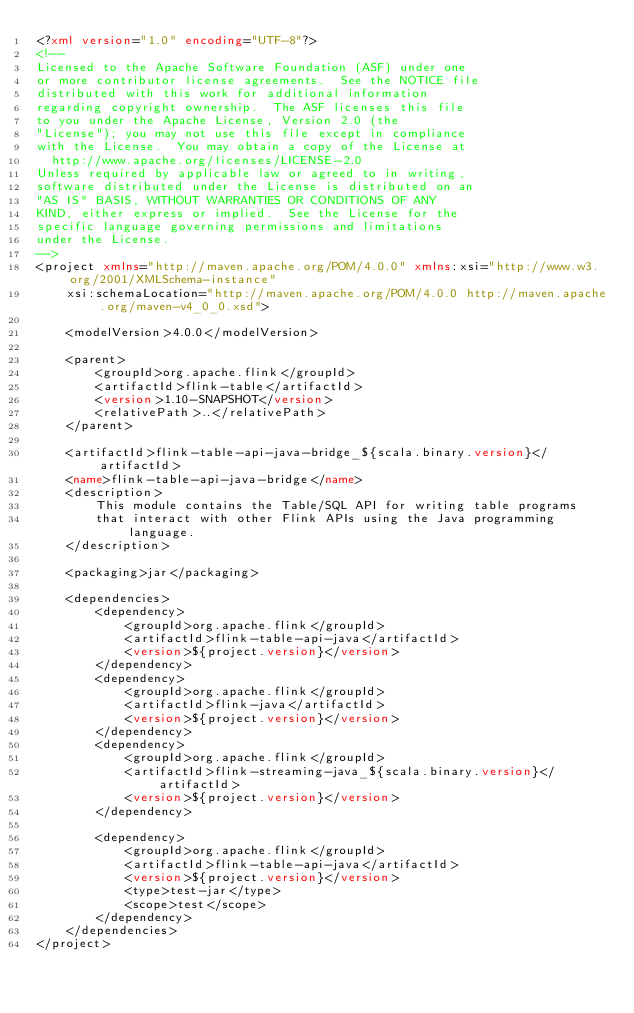<code> <loc_0><loc_0><loc_500><loc_500><_XML_><?xml version="1.0" encoding="UTF-8"?>
<!--
Licensed to the Apache Software Foundation (ASF) under one
or more contributor license agreements.  See the NOTICE file
distributed with this work for additional information
regarding copyright ownership.  The ASF licenses this file
to you under the Apache License, Version 2.0 (the
"License"); you may not use this file except in compliance
with the License.  You may obtain a copy of the License at
  http://www.apache.org/licenses/LICENSE-2.0
Unless required by applicable law or agreed to in writing,
software distributed under the License is distributed on an
"AS IS" BASIS, WITHOUT WARRANTIES OR CONDITIONS OF ANY
KIND, either express or implied.  See the License for the
specific language governing permissions and limitations
under the License.
-->
<project xmlns="http://maven.apache.org/POM/4.0.0" xmlns:xsi="http://www.w3.org/2001/XMLSchema-instance"
	xsi:schemaLocation="http://maven.apache.org/POM/4.0.0 http://maven.apache.org/maven-v4_0_0.xsd">

	<modelVersion>4.0.0</modelVersion>

	<parent>
		<groupId>org.apache.flink</groupId>
		<artifactId>flink-table</artifactId>
		<version>1.10-SNAPSHOT</version>
		<relativePath>..</relativePath>
	</parent>

	<artifactId>flink-table-api-java-bridge_${scala.binary.version}</artifactId>
	<name>flink-table-api-java-bridge</name>
	<description>
		This module contains the Table/SQL API for writing table programs
		that interact with other Flink APIs using the Java programming language.
	</description>

	<packaging>jar</packaging>

	<dependencies>
		<dependency>
			<groupId>org.apache.flink</groupId>
			<artifactId>flink-table-api-java</artifactId>
			<version>${project.version}</version>
		</dependency>
		<dependency>
			<groupId>org.apache.flink</groupId>
			<artifactId>flink-java</artifactId>
			<version>${project.version}</version>
		</dependency>
		<dependency>
			<groupId>org.apache.flink</groupId>
			<artifactId>flink-streaming-java_${scala.binary.version}</artifactId>
			<version>${project.version}</version>
		</dependency>

		<dependency>
			<groupId>org.apache.flink</groupId>
			<artifactId>flink-table-api-java</artifactId>
			<version>${project.version}</version>
			<type>test-jar</type>
			<scope>test</scope>
		</dependency>
	</dependencies>
</project>
</code> 